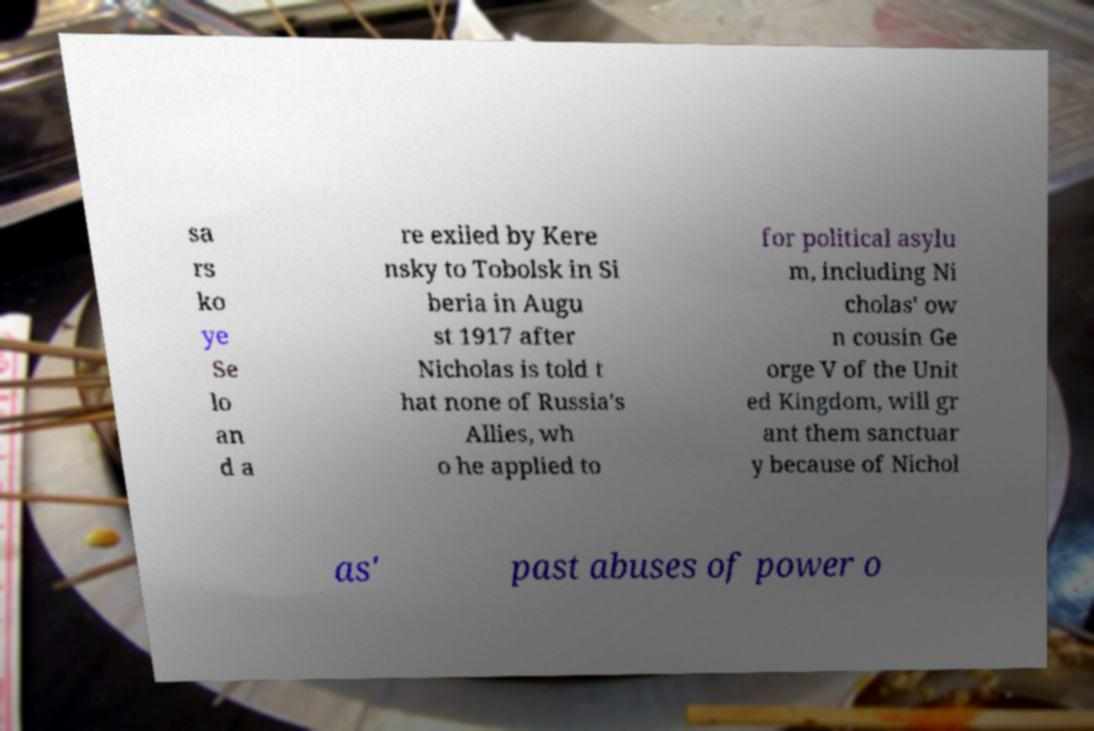Please read and relay the text visible in this image. What does it say? sa rs ko ye Se lo an d a re exiled by Kere nsky to Tobolsk in Si beria in Augu st 1917 after Nicholas is told t hat none of Russia's Allies, wh o he applied to for political asylu m, including Ni cholas' ow n cousin Ge orge V of the Unit ed Kingdom, will gr ant them sanctuar y because of Nichol as' past abuses of power o 